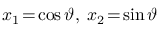Convert formula to latex. <formula><loc_0><loc_0><loc_500><loc_500>x _ { 1 } \, = \, \cos \vartheta , \, x _ { 2 } \, = \, \sin \vartheta</formula> 